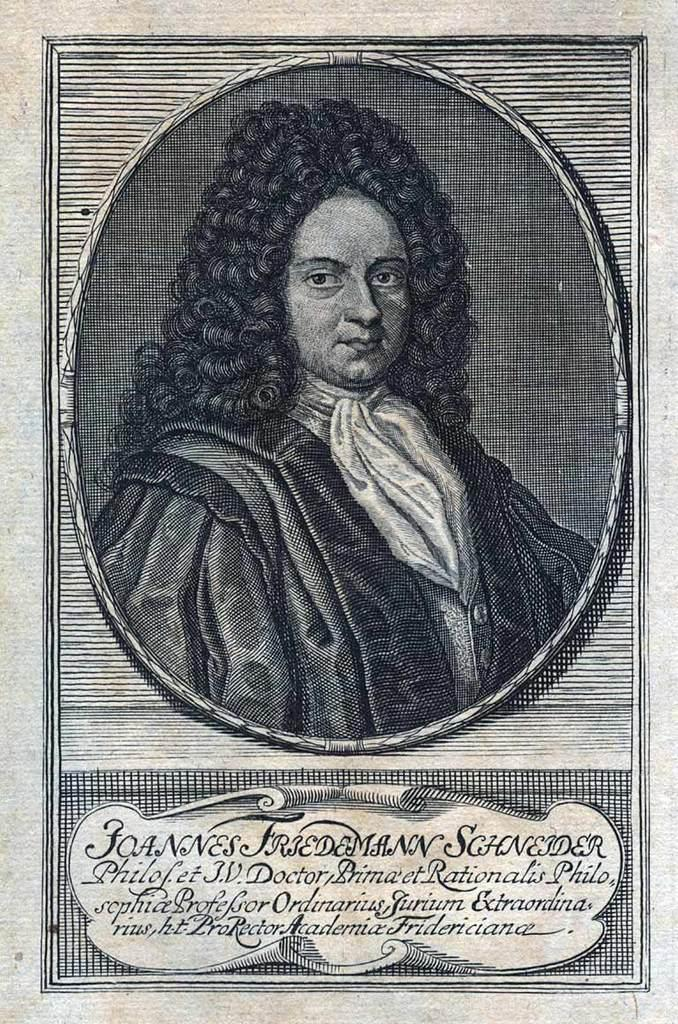<image>
Render a clear and concise summary of the photo. An image that looks like a lithograph of a person in a Victorian wig and clothing references Joannes Friedemann Schneider. 